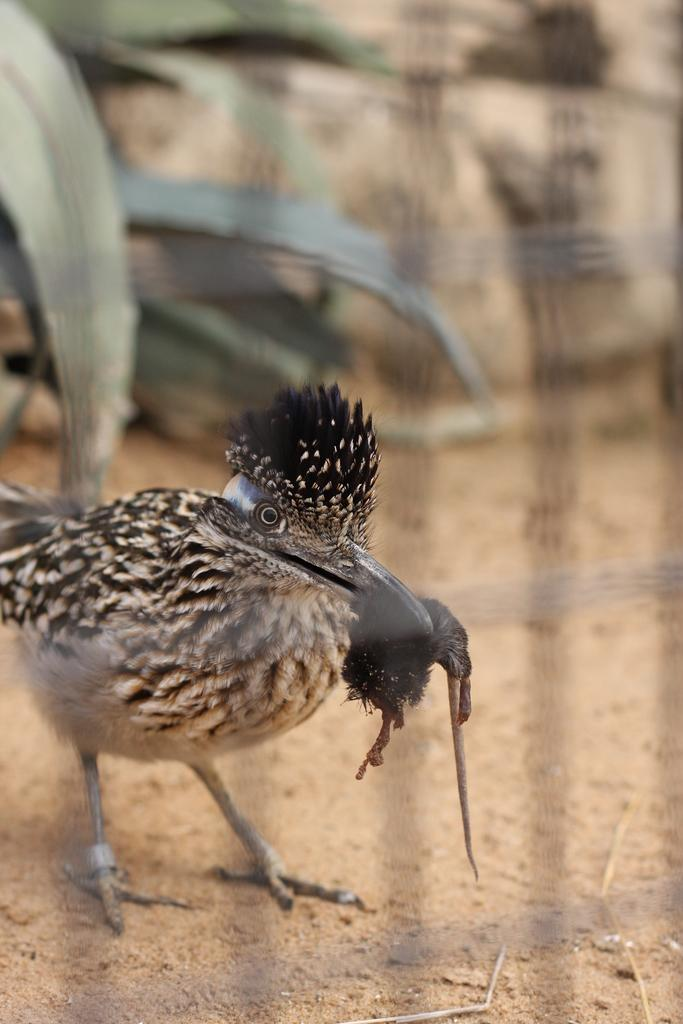What type of animal can be seen in the image? There is a bird in the image. What can be found in the top left corner of the image? There are leaves in the top left of the image. How would you describe the background of the image? The background of the image is blurred. What type of insect is participating in the activity in the hall in the image? There is no insect, activity, or hall present in the image. 